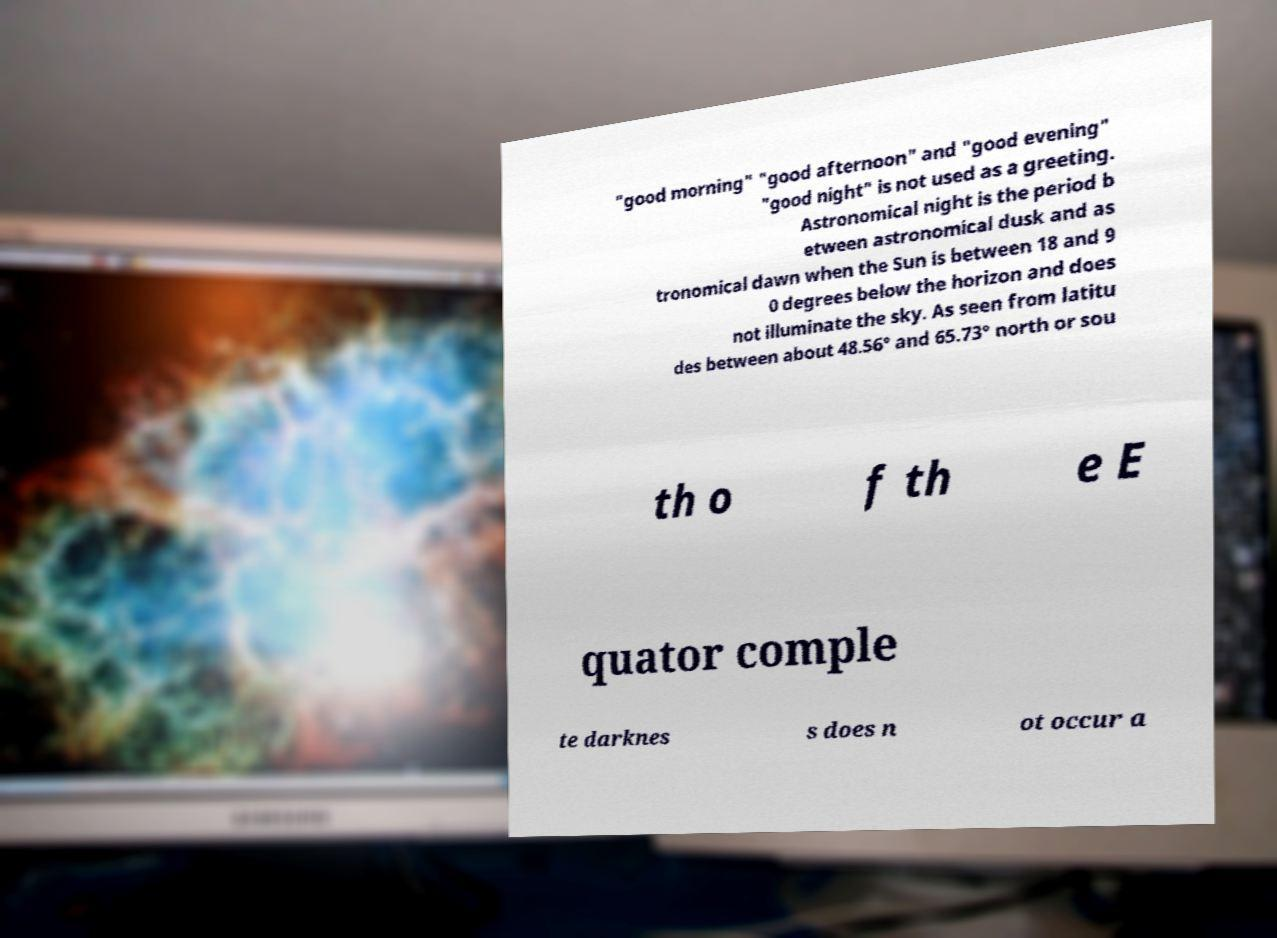Please read and relay the text visible in this image. What does it say? "good morning" "good afternoon" and "good evening" "good night" is not used as a greeting. Astronomical night is the period b etween astronomical dusk and as tronomical dawn when the Sun is between 18 and 9 0 degrees below the horizon and does not illuminate the sky. As seen from latitu des between about 48.56° and 65.73° north or sou th o f th e E quator comple te darknes s does n ot occur a 